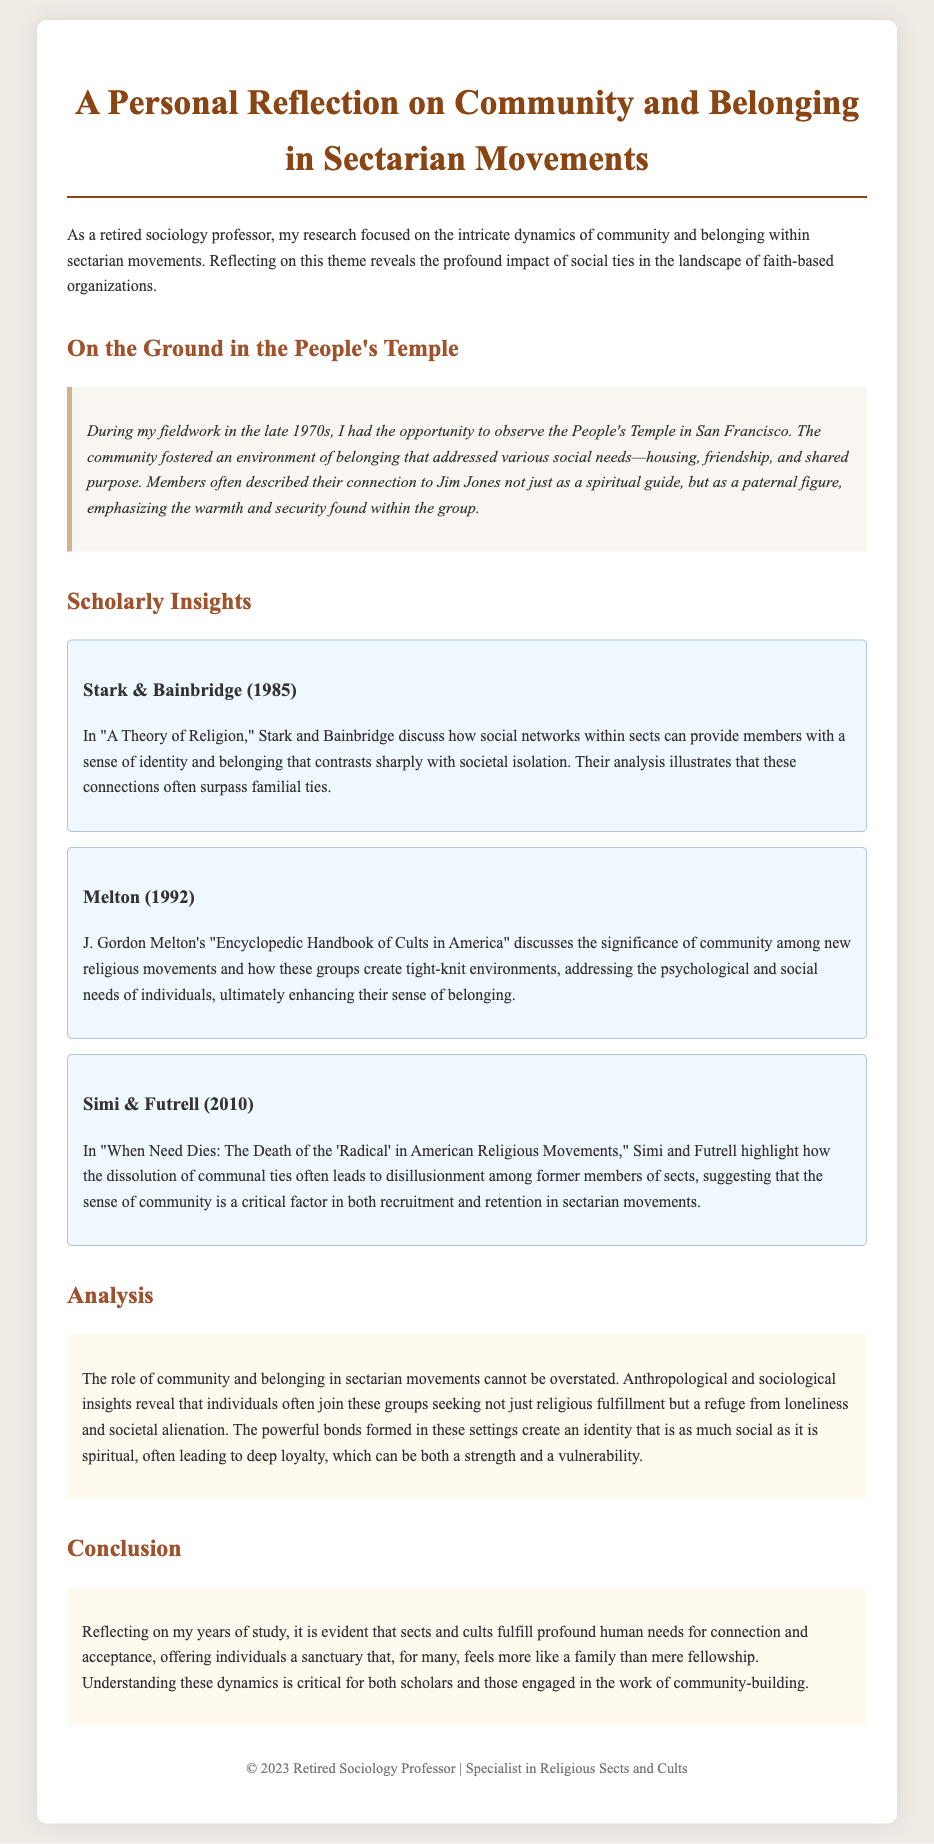What is the title of the document? The title of the document is mentioned at the top of the rendered document.
Answer: A Personal Reflection on Community and Belonging in Sectarian Movements Who was the leader of the People's Temple? The document references Jim Jones as a significant figure within the People's Temple community.
Answer: Jim Jones In what year was the fieldwork conducted? The fieldwork mentioned in the anecdote took place in the late 1970s.
Answer: Late 1970s Which authors proposed a theory in 1985 related to religion? The document cites Stark and Bainbridge in connection with their work from 1985 on social networks in sects.
Answer: Stark & Bainbridge What kind of needs do sects typically address according to Melton? Melton discusses that new religious movements address psychological and social needs.
Answer: Psychological and social needs What is a key factor in both recruitment and retention in sectarian movements? The document highlights communal ties as essential for recruitment and retention of members.
Answer: Communal ties What analytical fields are mentioned as part of the insights on sectarian movements? The document notes both anthropological and sociological insights regarding community in sects.
Answer: Anthropological and sociological What does the reflection suggest about the feeling of belonging in sectarian movements? The conclusion emphasizes that sects fulfill needs for connection and acceptance, akin to family.
Answer: Needs for connection and acceptance How do former members typically feel about the dissolution of communal ties? The document suggests that disillusionment often arises from the dissolution of communal ties.
Answer: Disillusionment 